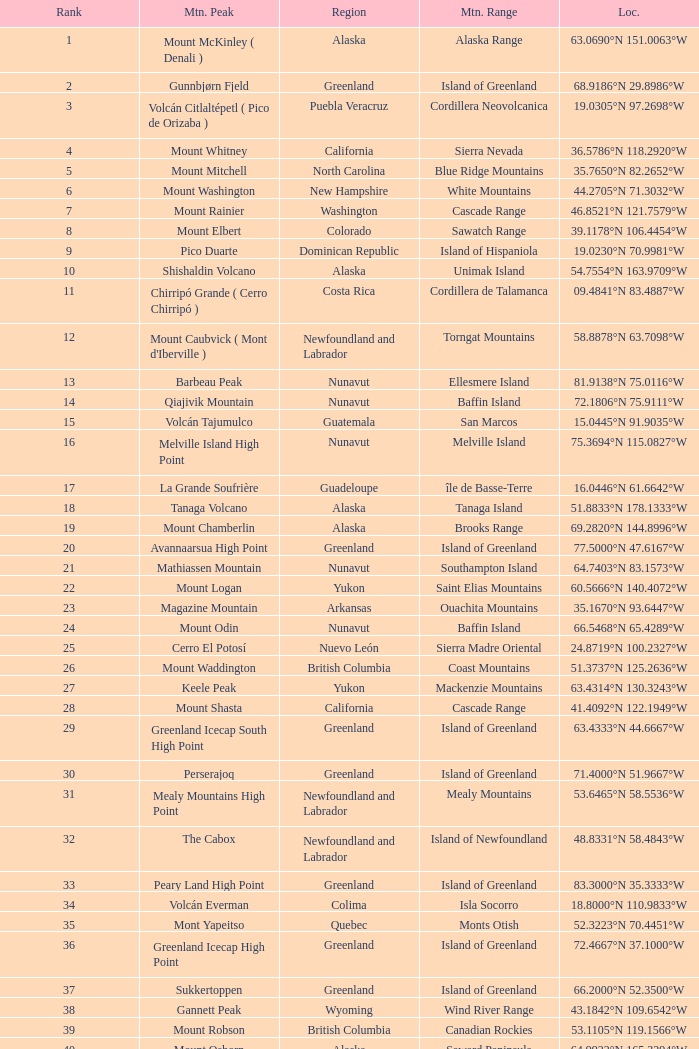In which mountain range can a region of haiti be found, located at 18.3601°n 71.9764°w? Island of Hispaniola. 